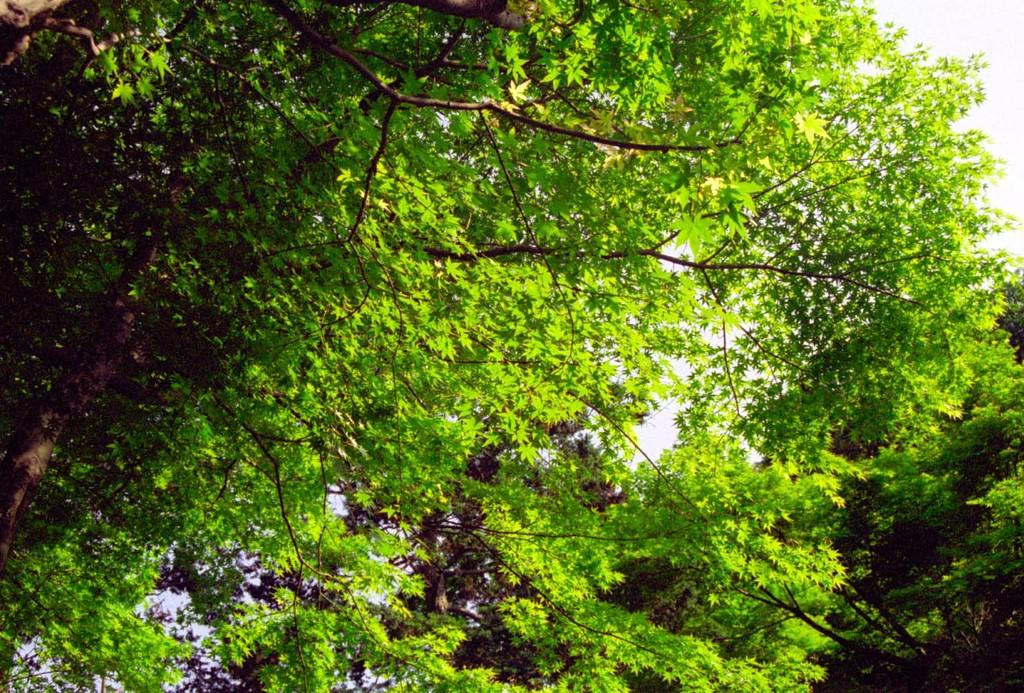What type of vegetation can be seen in the image? There are trees in the image. What is the color of the sky in the image? The sky is white in the image. Where is the chair located in the image? There is no chair present in the image. What type of garden can be seen in the image? There is no garden present in the image. 